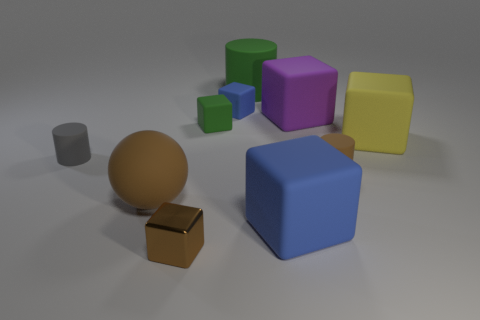Subtract 1 blocks. How many blocks are left? 5 Subtract all red spheres. How many blue blocks are left? 2 Subtract all purple cubes. How many cubes are left? 5 Subtract all small green matte blocks. How many blocks are left? 5 Subtract all yellow blocks. Subtract all brown balls. How many blocks are left? 5 Subtract all spheres. How many objects are left? 9 Subtract all big spheres. Subtract all large brown rubber objects. How many objects are left? 8 Add 3 small brown things. How many small brown things are left? 5 Add 8 red spheres. How many red spheres exist? 8 Subtract 0 gray cubes. How many objects are left? 10 